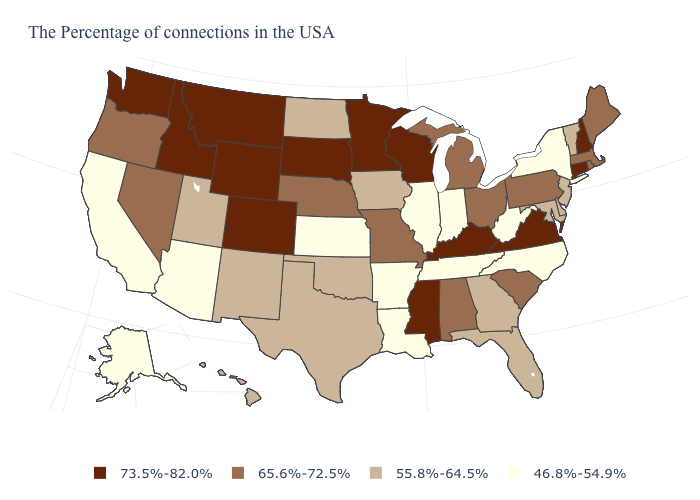Does Rhode Island have the highest value in the USA?
Give a very brief answer. No. What is the value of Alaska?
Concise answer only. 46.8%-54.9%. What is the value of Virginia?
Short answer required. 73.5%-82.0%. Among the states that border Mississippi , which have the lowest value?
Answer briefly. Tennessee, Louisiana, Arkansas. Name the states that have a value in the range 65.6%-72.5%?
Concise answer only. Maine, Massachusetts, Rhode Island, Pennsylvania, South Carolina, Ohio, Michigan, Alabama, Missouri, Nebraska, Nevada, Oregon. What is the value of Nebraska?
Concise answer only. 65.6%-72.5%. Name the states that have a value in the range 65.6%-72.5%?
Keep it brief. Maine, Massachusetts, Rhode Island, Pennsylvania, South Carolina, Ohio, Michigan, Alabama, Missouri, Nebraska, Nevada, Oregon. What is the highest value in states that border Illinois?
Write a very short answer. 73.5%-82.0%. Among the states that border Colorado , does Kansas have the highest value?
Concise answer only. No. What is the value of Maine?
Concise answer only. 65.6%-72.5%. What is the value of Arizona?
Give a very brief answer. 46.8%-54.9%. What is the value of Washington?
Short answer required. 73.5%-82.0%. Among the states that border Montana , does South Dakota have the highest value?
Concise answer only. Yes. Is the legend a continuous bar?
Quick response, please. No. Name the states that have a value in the range 55.8%-64.5%?
Write a very short answer. Vermont, New Jersey, Delaware, Maryland, Florida, Georgia, Iowa, Oklahoma, Texas, North Dakota, New Mexico, Utah, Hawaii. 